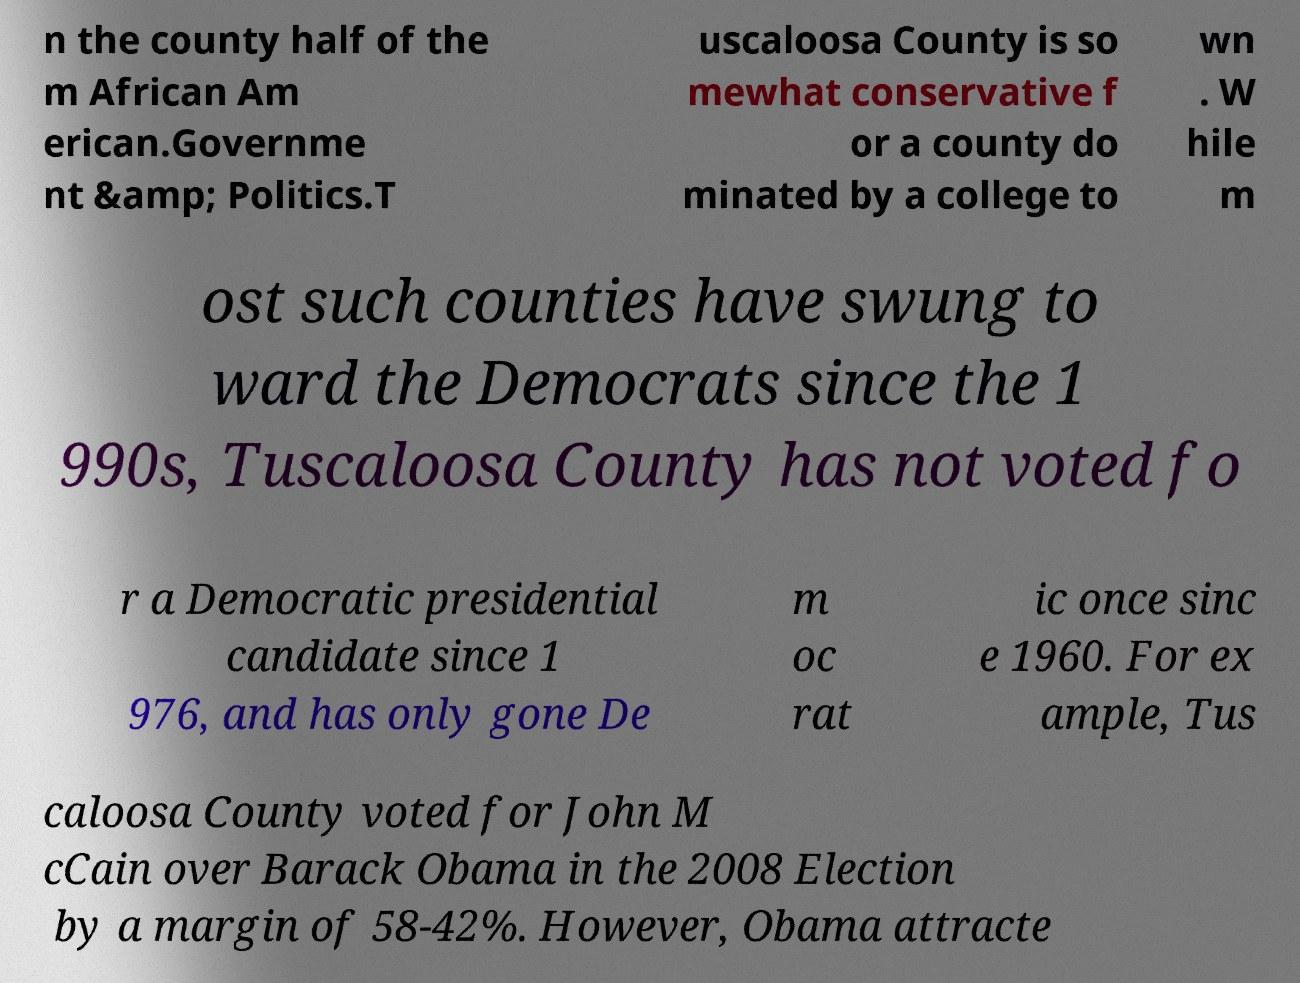I need the written content from this picture converted into text. Can you do that? n the county half of the m African Am erican.Governme nt &amp; Politics.T uscaloosa County is so mewhat conservative f or a county do minated by a college to wn . W hile m ost such counties have swung to ward the Democrats since the 1 990s, Tuscaloosa County has not voted fo r a Democratic presidential candidate since 1 976, and has only gone De m oc rat ic once sinc e 1960. For ex ample, Tus caloosa County voted for John M cCain over Barack Obama in the 2008 Election by a margin of 58-42%. However, Obama attracte 